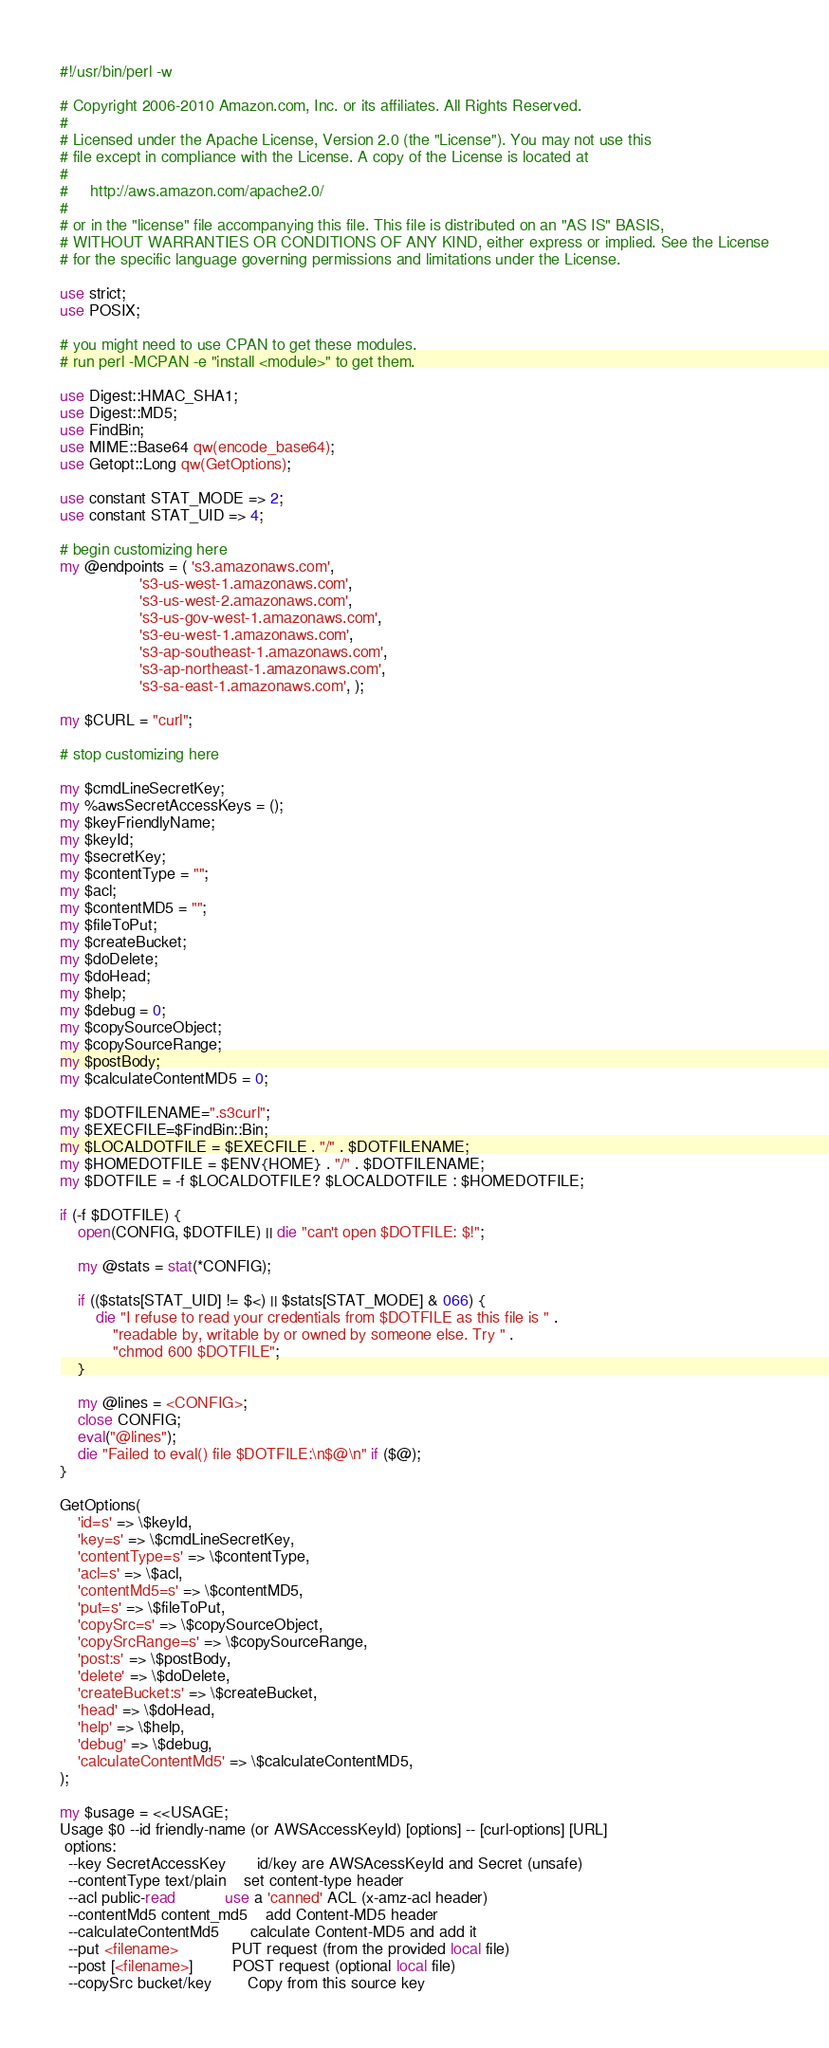Convert code to text. <code><loc_0><loc_0><loc_500><loc_500><_Perl_>#!/usr/bin/perl -w

# Copyright 2006-2010 Amazon.com, Inc. or its affiliates. All Rights Reserved.
#
# Licensed under the Apache License, Version 2.0 (the "License"). You may not use this
# file except in compliance with the License. A copy of the License is located at
#
#     http://aws.amazon.com/apache2.0/
#
# or in the "license" file accompanying this file. This file is distributed on an "AS IS" BASIS,
# WITHOUT WARRANTIES OR CONDITIONS OF ANY KIND, either express or implied. See the License
# for the specific language governing permissions and limitations under the License.

use strict;
use POSIX;

# you might need to use CPAN to get these modules.
# run perl -MCPAN -e "install <module>" to get them.

use Digest::HMAC_SHA1;
use Digest::MD5;
use FindBin;
use MIME::Base64 qw(encode_base64);
use Getopt::Long qw(GetOptions);

use constant STAT_MODE => 2;
use constant STAT_UID => 4;

# begin customizing here
my @endpoints = ( 's3.amazonaws.com',
                  's3-us-west-1.amazonaws.com',
                  's3-us-west-2.amazonaws.com',
                  's3-us-gov-west-1.amazonaws.com',
                  's3-eu-west-1.amazonaws.com',
                  's3-ap-southeast-1.amazonaws.com',
                  's3-ap-northeast-1.amazonaws.com',
                  's3-sa-east-1.amazonaws.com', );

my $CURL = "curl";

# stop customizing here

my $cmdLineSecretKey;
my %awsSecretAccessKeys = ();
my $keyFriendlyName;
my $keyId;
my $secretKey;
my $contentType = "";
my $acl;
my $contentMD5 = "";
my $fileToPut;
my $createBucket;
my $doDelete;
my $doHead;
my $help;
my $debug = 0;
my $copySourceObject;
my $copySourceRange;
my $postBody;
my $calculateContentMD5 = 0;

my $DOTFILENAME=".s3curl";
my $EXECFILE=$FindBin::Bin;
my $LOCALDOTFILE = $EXECFILE . "/" . $DOTFILENAME;
my $HOMEDOTFILE = $ENV{HOME} . "/" . $DOTFILENAME;
my $DOTFILE = -f $LOCALDOTFILE? $LOCALDOTFILE : $HOMEDOTFILE;

if (-f $DOTFILE) {
    open(CONFIG, $DOTFILE) || die "can't open $DOTFILE: $!";

    my @stats = stat(*CONFIG);

    if (($stats[STAT_UID] != $<) || $stats[STAT_MODE] & 066) {
        die "I refuse to read your credentials from $DOTFILE as this file is " .
            "readable by, writable by or owned by someone else. Try " .
            "chmod 600 $DOTFILE";
    }

    my @lines = <CONFIG>;
    close CONFIG;
    eval("@lines");
    die "Failed to eval() file $DOTFILE:\n$@\n" if ($@);
}

GetOptions(
    'id=s' => \$keyId,
    'key=s' => \$cmdLineSecretKey,
    'contentType=s' => \$contentType,
    'acl=s' => \$acl,
    'contentMd5=s' => \$contentMD5,
    'put=s' => \$fileToPut,
    'copySrc=s' => \$copySourceObject,
    'copySrcRange=s' => \$copySourceRange,
    'post:s' => \$postBody,
    'delete' => \$doDelete,
    'createBucket:s' => \$createBucket,
    'head' => \$doHead,
    'help' => \$help,
    'debug' => \$debug,
    'calculateContentMd5' => \$calculateContentMD5,
);

my $usage = <<USAGE;
Usage $0 --id friendly-name (or AWSAccessKeyId) [options] -- [curl-options] [URL]
 options:
  --key SecretAccessKey       id/key are AWSAcessKeyId and Secret (unsafe)
  --contentType text/plain    set content-type header
  --acl public-read           use a 'canned' ACL (x-amz-acl header)
  --contentMd5 content_md5    add Content-MD5 header
  --calculateContentMd5       calculate Content-MD5 and add it
  --put <filename>            PUT request (from the provided local file)
  --post [<filename>]         POST request (optional local file)
  --copySrc bucket/key        Copy from this source key</code> 